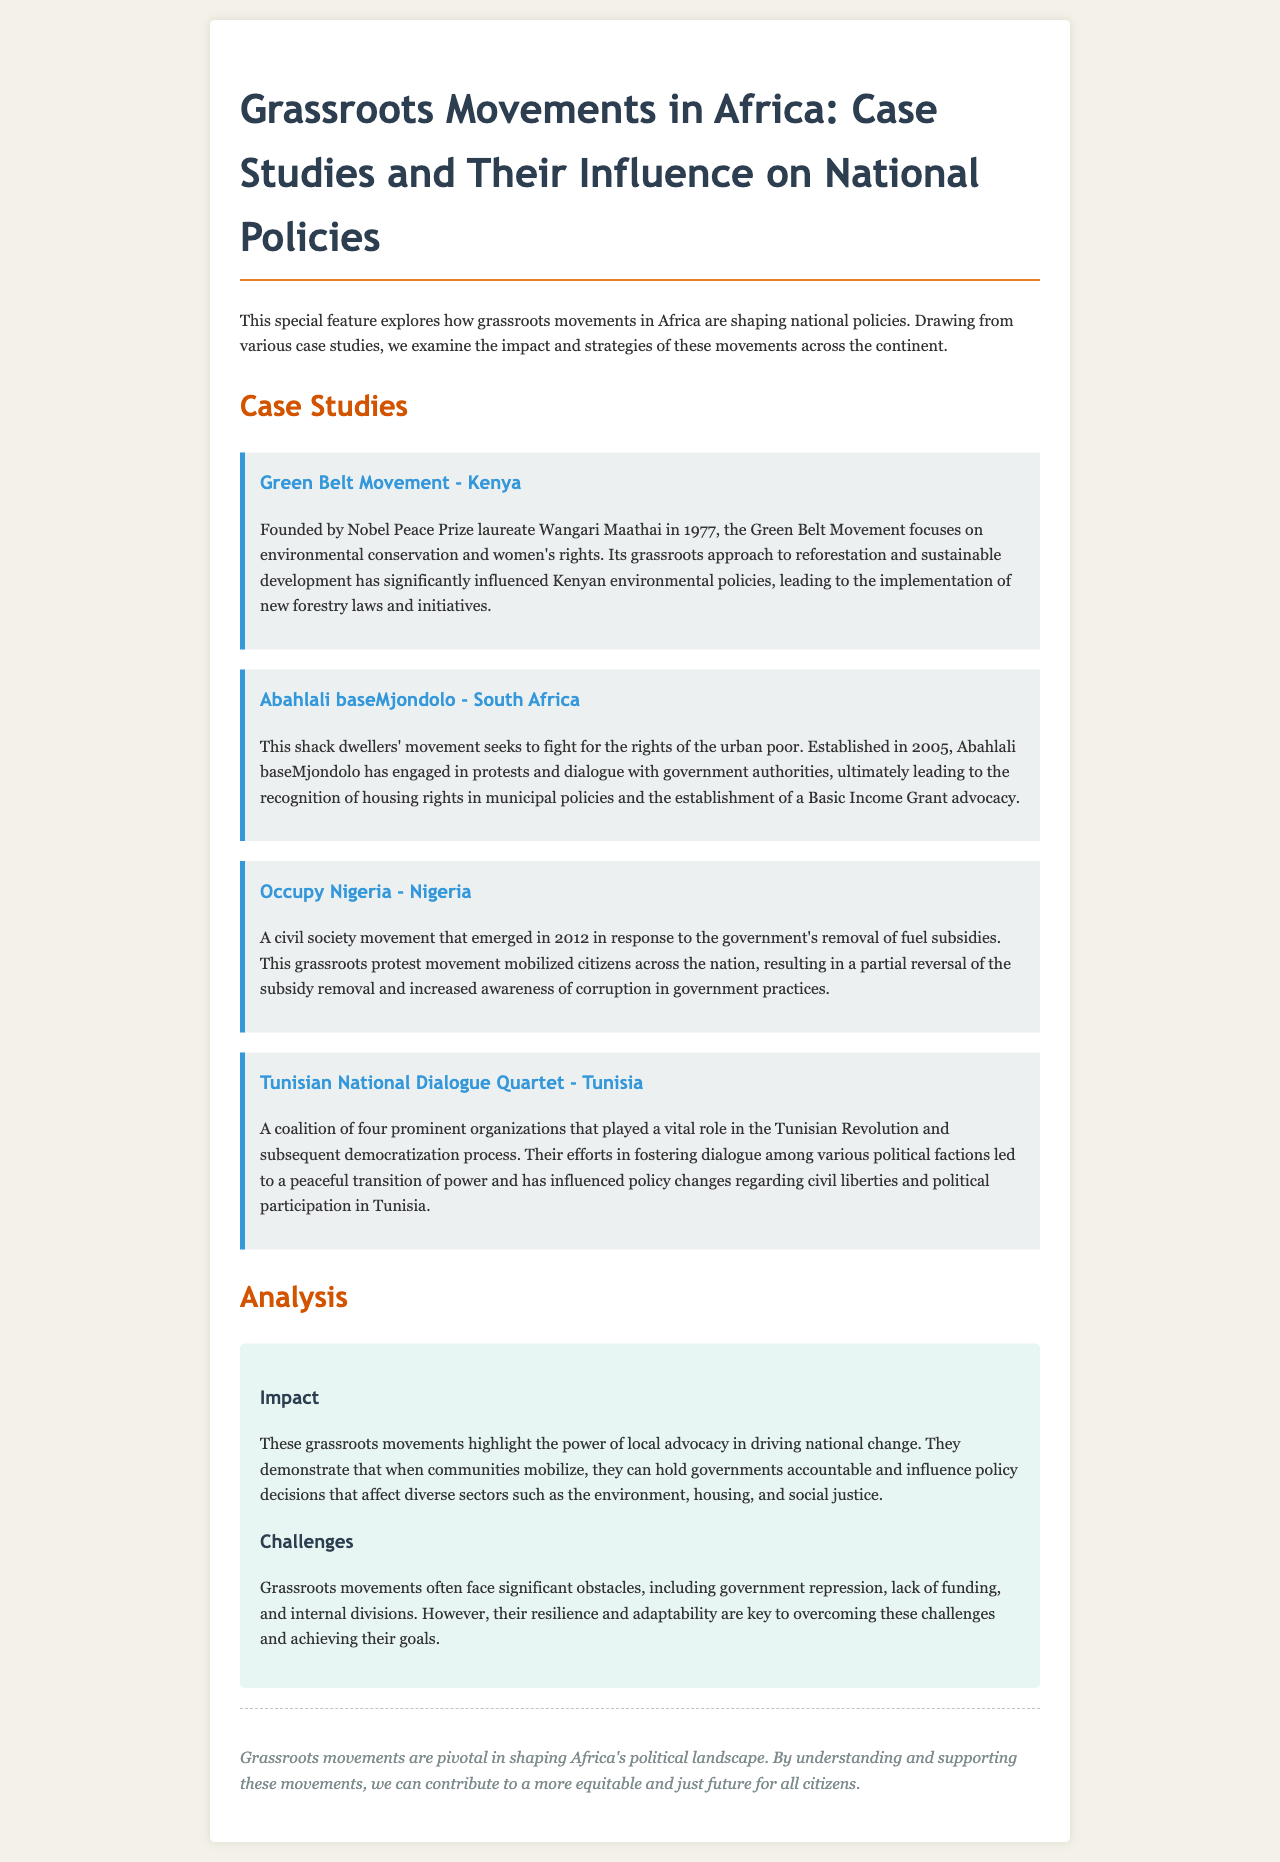What is the title of the newsletter? The title of the newsletter is mentioned at the top of the document.
Answer: Grassroots Movements in Africa: Case Studies and Their Influence on National Policies Who founded the Green Belt Movement? The document specifies that the Green Belt Movement was founded by a notable figure.
Answer: Wangari Maathai In what year was Abahlali baseMjondolo established? The establishment year of the movement is clearly stated in the case study.
Answer: 2005 What national policy was influenced by Occupy Nigeria? The document discusses the outcome of the movement and its impact on government policies.
Answer: Fuel subsidies Which coalition played a vital role in the Tunisian Revolution? The coalition's name is highlighted in the case study.
Answer: Tunisian National Dialogue Quartet What is one challenge faced by grassroots movements mentioned in the analysis? The document outlines various obstacles faced by these movements.
Answer: Government repression How do grassroots movements affect national policies? The analysis section explains the broader effects of these movements.
Answer: Hold governments accountable What type of document is this? The structure and content indicate the type of document.
Answer: Newsletter 